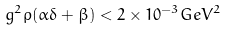Convert formula to latex. <formula><loc_0><loc_0><loc_500><loc_500>g ^ { 2 } \rho ( \alpha \delta + \beta ) < 2 \times 1 0 ^ { - 3 } G e V ^ { 2 }</formula> 